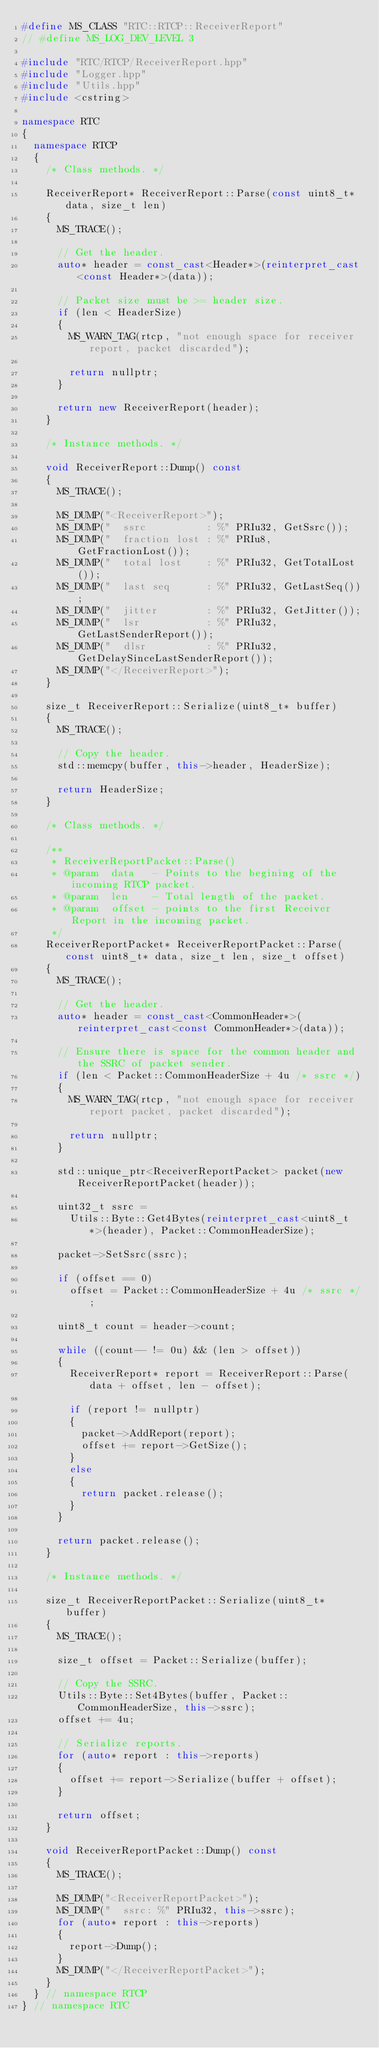<code> <loc_0><loc_0><loc_500><loc_500><_C++_>#define MS_CLASS "RTC::RTCP::ReceiverReport"
// #define MS_LOG_DEV_LEVEL 3

#include "RTC/RTCP/ReceiverReport.hpp"
#include "Logger.hpp"
#include "Utils.hpp"
#include <cstring>

namespace RTC
{
	namespace RTCP
	{
		/* Class methods. */

		ReceiverReport* ReceiverReport::Parse(const uint8_t* data, size_t len)
		{
			MS_TRACE();

			// Get the header.
			auto* header = const_cast<Header*>(reinterpret_cast<const Header*>(data));

			// Packet size must be >= header size.
			if (len < HeaderSize)
			{
				MS_WARN_TAG(rtcp, "not enough space for receiver report, packet discarded");

				return nullptr;
			}

			return new ReceiverReport(header);
		}

		/* Instance methods. */

		void ReceiverReport::Dump() const
		{
			MS_TRACE();

			MS_DUMP("<ReceiverReport>");
			MS_DUMP("  ssrc          : %" PRIu32, GetSsrc());
			MS_DUMP("  fraction lost : %" PRIu8, GetFractionLost());
			MS_DUMP("  total lost    : %" PRIu32, GetTotalLost());
			MS_DUMP("  last seq      : %" PRIu32, GetLastSeq());
			MS_DUMP("  jitter        : %" PRIu32, GetJitter());
			MS_DUMP("  lsr           : %" PRIu32, GetLastSenderReport());
			MS_DUMP("  dlsr          : %" PRIu32, GetDelaySinceLastSenderReport());
			MS_DUMP("</ReceiverReport>");
		}

		size_t ReceiverReport::Serialize(uint8_t* buffer)
		{
			MS_TRACE();

			// Copy the header.
			std::memcpy(buffer, this->header, HeaderSize);

			return HeaderSize;
		}

		/* Class methods. */

		/**
		 * ReceiverReportPacket::Parse()
		 * @param  data   - Points to the begining of the incoming RTCP packet.
		 * @param  len    - Total length of the packet.
		 * @param  offset - points to the first Receiver Report in the incoming packet.
		 */
		ReceiverReportPacket* ReceiverReportPacket::Parse(const uint8_t* data, size_t len, size_t offset)
		{
			MS_TRACE();

			// Get the header.
			auto* header = const_cast<CommonHeader*>(reinterpret_cast<const CommonHeader*>(data));

			// Ensure there is space for the common header and the SSRC of packet sender.
			if (len < Packet::CommonHeaderSize + 4u /* ssrc */)
			{
				MS_WARN_TAG(rtcp, "not enough space for receiver report packet, packet discarded");

				return nullptr;
			}

			std::unique_ptr<ReceiverReportPacket> packet(new ReceiverReportPacket(header));

			uint32_t ssrc =
			  Utils::Byte::Get4Bytes(reinterpret_cast<uint8_t*>(header), Packet::CommonHeaderSize);

			packet->SetSsrc(ssrc);

			if (offset == 0)
				offset = Packet::CommonHeaderSize + 4u /* ssrc */;

			uint8_t count = header->count;

			while ((count-- != 0u) && (len > offset))
			{
				ReceiverReport* report = ReceiverReport::Parse(data + offset, len - offset);

				if (report != nullptr)
				{
					packet->AddReport(report);
					offset += report->GetSize();
				}
				else
				{
					return packet.release();
				}
			}

			return packet.release();
		}

		/* Instance methods. */

		size_t ReceiverReportPacket::Serialize(uint8_t* buffer)
		{
			MS_TRACE();

			size_t offset = Packet::Serialize(buffer);

			// Copy the SSRC.
			Utils::Byte::Set4Bytes(buffer, Packet::CommonHeaderSize, this->ssrc);
			offset += 4u;

			// Serialize reports.
			for (auto* report : this->reports)
			{
				offset += report->Serialize(buffer + offset);
			}

			return offset;
		}

		void ReceiverReportPacket::Dump() const
		{
			MS_TRACE();

			MS_DUMP("<ReceiverReportPacket>");
			MS_DUMP("  ssrc: %" PRIu32, this->ssrc);
			for (auto* report : this->reports)
			{
				report->Dump();
			}
			MS_DUMP("</ReceiverReportPacket>");
		}
	} // namespace RTCP
} // namespace RTC
</code> 